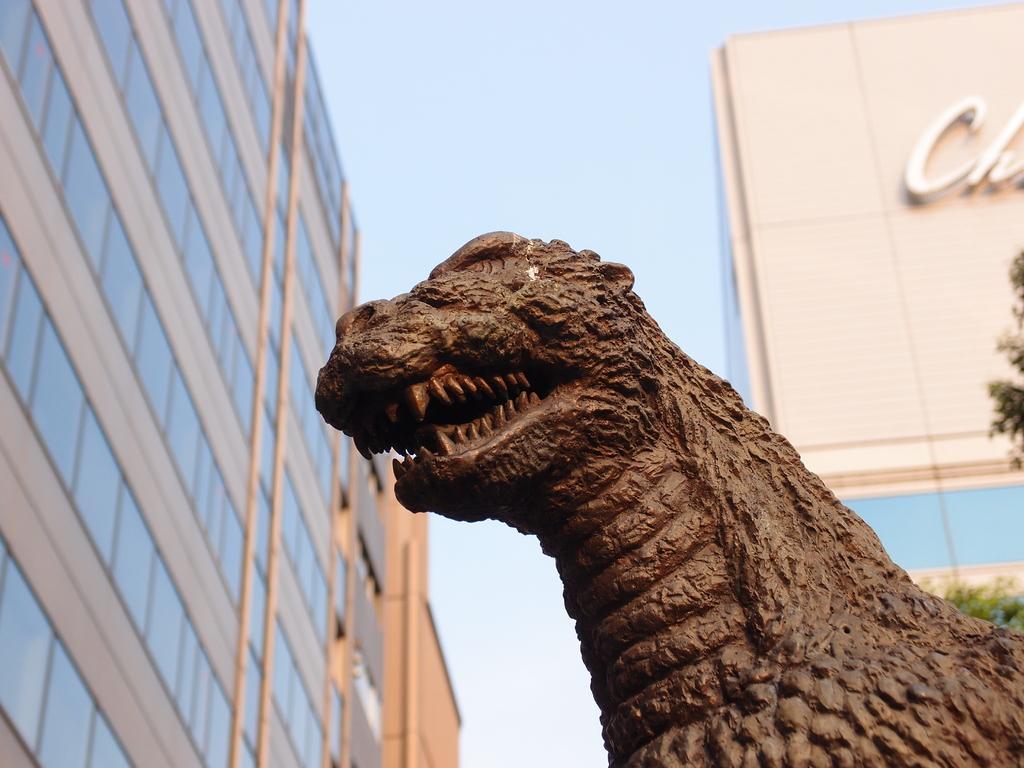In one or two sentences, can you explain what this image depicts? In this picture I can see buildings and couple of tree branches and I can see statue of a animal and a cloudy sky and I can see text on the wall of the building. 